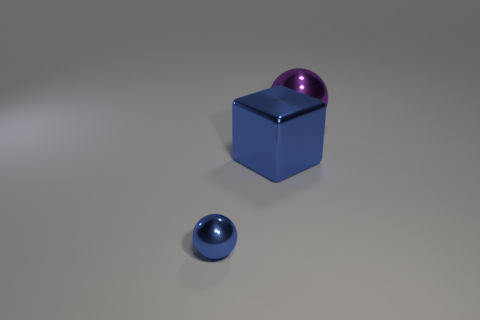There is a blue thing that is the same size as the purple metal thing; what is its material? metal 